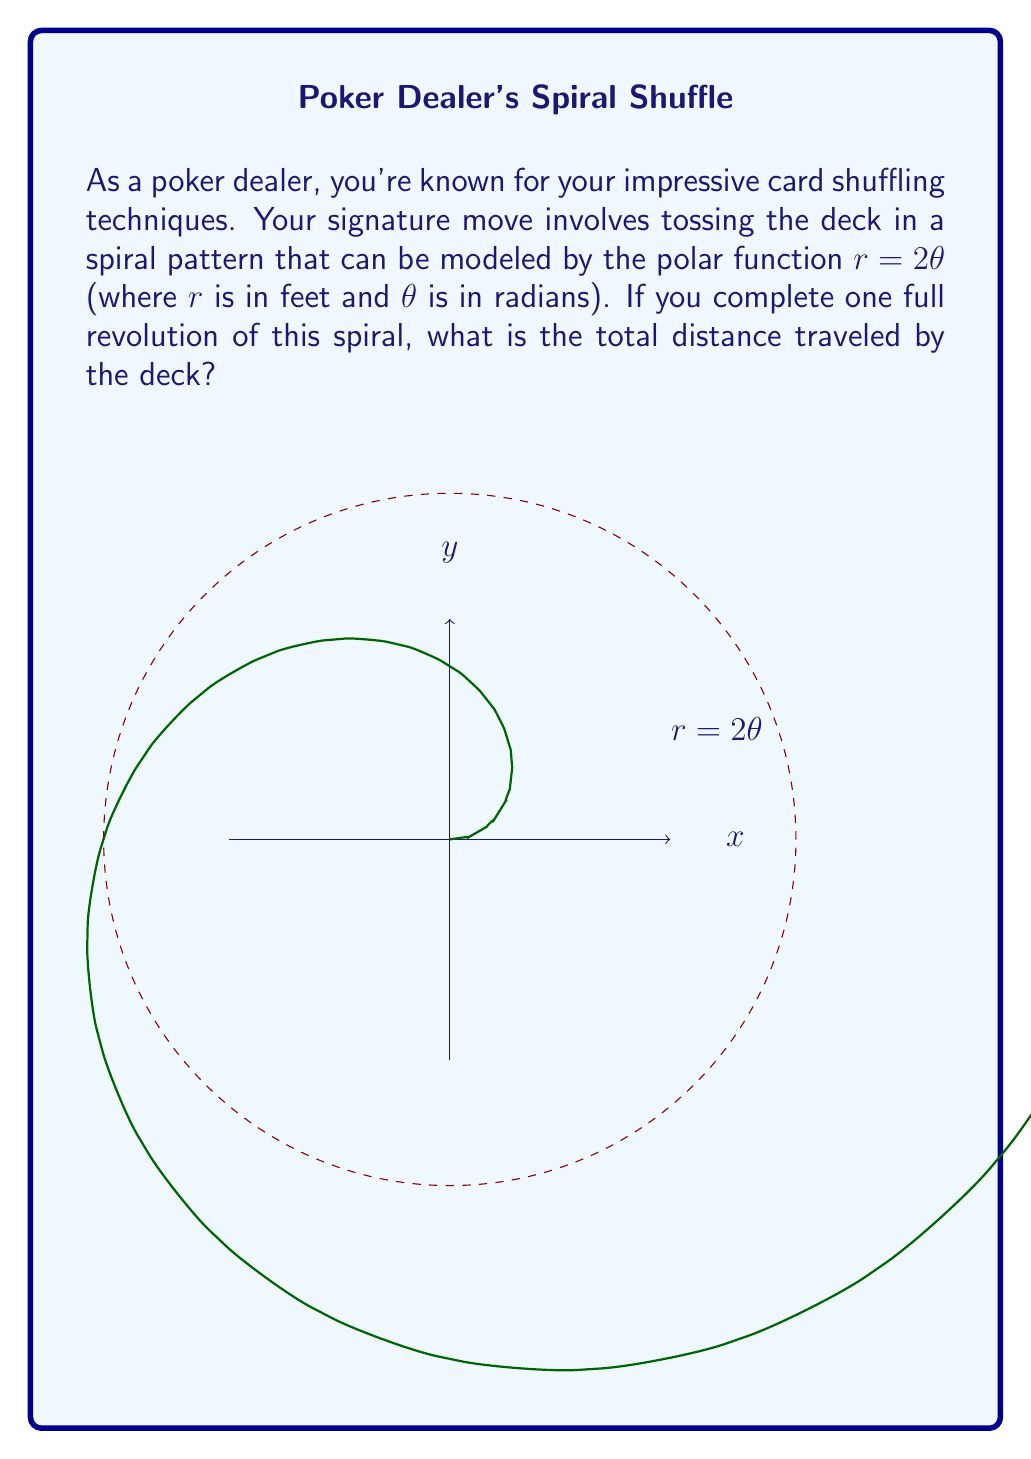Give your solution to this math problem. Let's approach this step-by-step:

1) The polar function given is $r = 2\theta$, where $r$ is in feet and $\theta$ is in radians.

2) To find the total distance traveled, we need to calculate the arc length of this spiral for one full revolution (i.e., from $\theta = 0$ to $\theta = 2\pi$).

3) The formula for arc length in polar coordinates is:

   $$L = \int_a^b \sqrt{r^2 + \left(\frac{dr}{d\theta}\right)^2} d\theta$$

4) For our function $r = 2\theta$:
   $r = 2\theta$
   $\frac{dr}{d\theta} = 2$

5) Substituting into the arc length formula:

   $$L = \int_0^{2\pi} \sqrt{(2\theta)^2 + 2^2} d\theta$$

6) Simplifying under the square root:

   $$L = \int_0^{2\pi} \sqrt{4\theta^2 + 4} d\theta$$
   $$L = 2\int_0^{2\pi} \sqrt{\theta^2 + 1} d\theta$$

7) This integral doesn't have an elementary antiderivative. We need to use the hyperbolic functions:

   $$L = 2[\theta \sinh^{-1}(\theta) + \sqrt{\theta^2 + 1}]_0^{2\pi}$$

8) Evaluating at the limits:

   $$L = 2[(2\pi \sinh^{-1}(2\pi) + \sqrt{4\pi^2 + 1}) - (0 + 1)]$$
   $$L = 2[2\pi \sinh^{-1}(2\pi) + \sqrt{4\pi^2 + 1} - 1]$$

9) This can be evaluated numerically to get the final answer.
Answer: $2[2\pi \sinh^{-1}(2\pi) + \sqrt{4\pi^2 + 1} - 1] \approx 44.8$ feet 